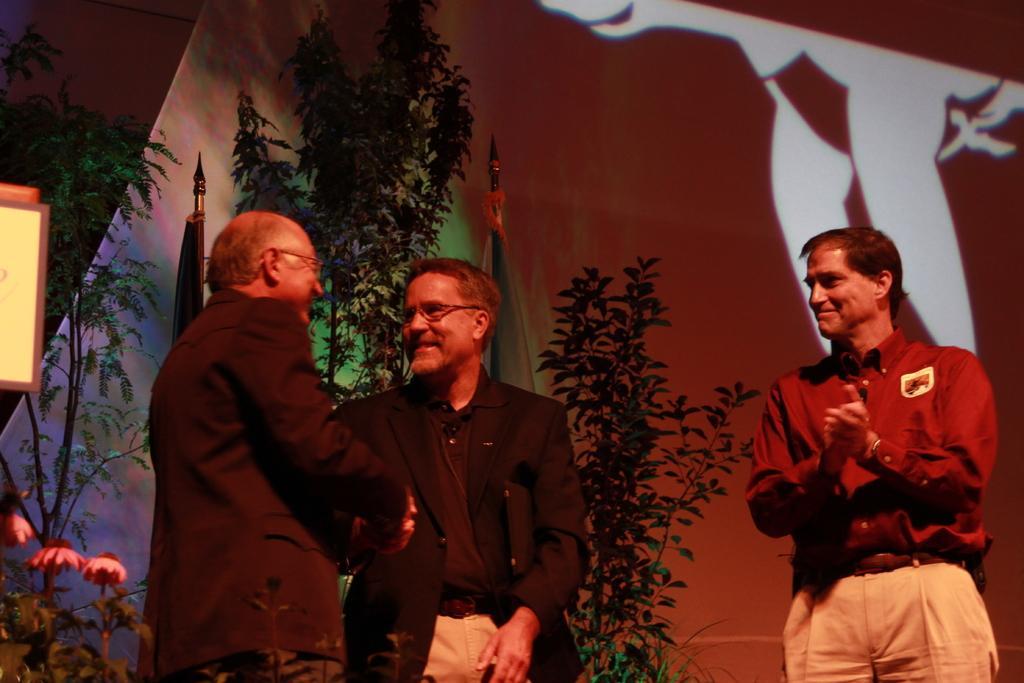In one or two sentences, can you explain what this image depicts? In this image there are people standing. In the background there are trees and flags. We can see a curtain. 